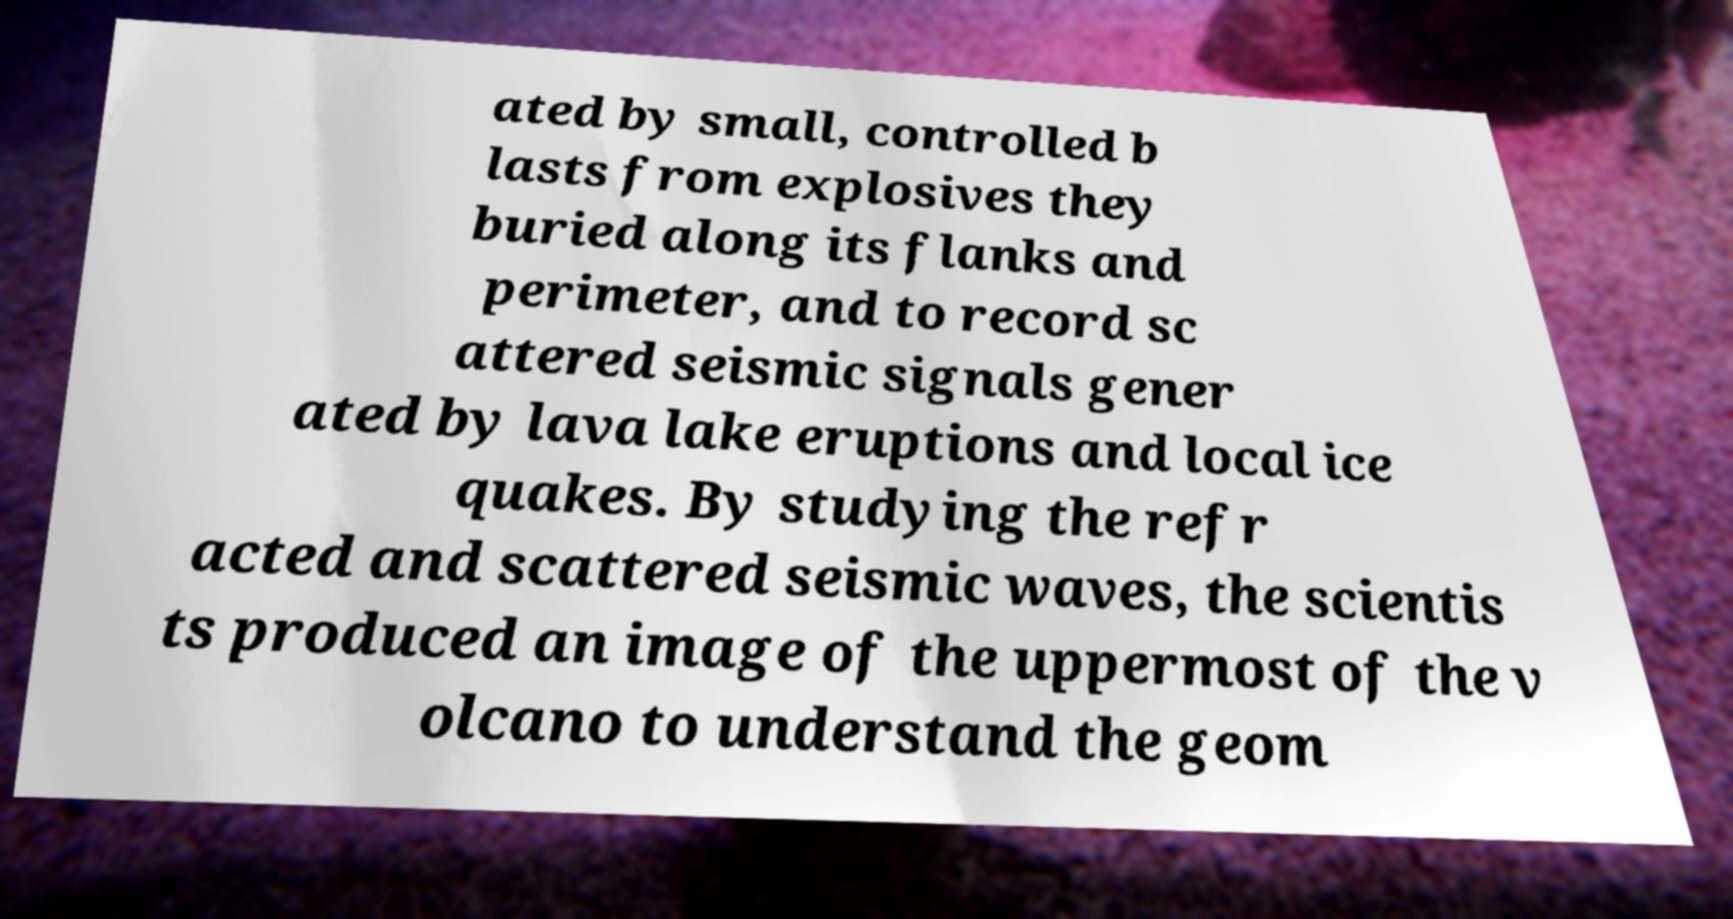I need the written content from this picture converted into text. Can you do that? ated by small, controlled b lasts from explosives they buried along its flanks and perimeter, and to record sc attered seismic signals gener ated by lava lake eruptions and local ice quakes. By studying the refr acted and scattered seismic waves, the scientis ts produced an image of the uppermost of the v olcano to understand the geom 